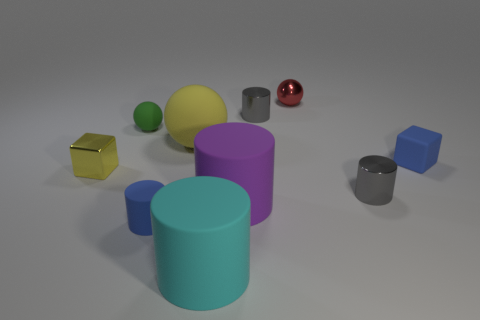Subtract 1 cylinders. How many cylinders are left? 4 Subtract all cyan cylinders. How many cylinders are left? 4 Subtract all balls. How many objects are left? 7 Add 2 small red metal balls. How many small red metal balls exist? 3 Subtract 1 blue cylinders. How many objects are left? 9 Subtract all tiny green matte spheres. Subtract all spheres. How many objects are left? 6 Add 7 small gray things. How many small gray things are left? 9 